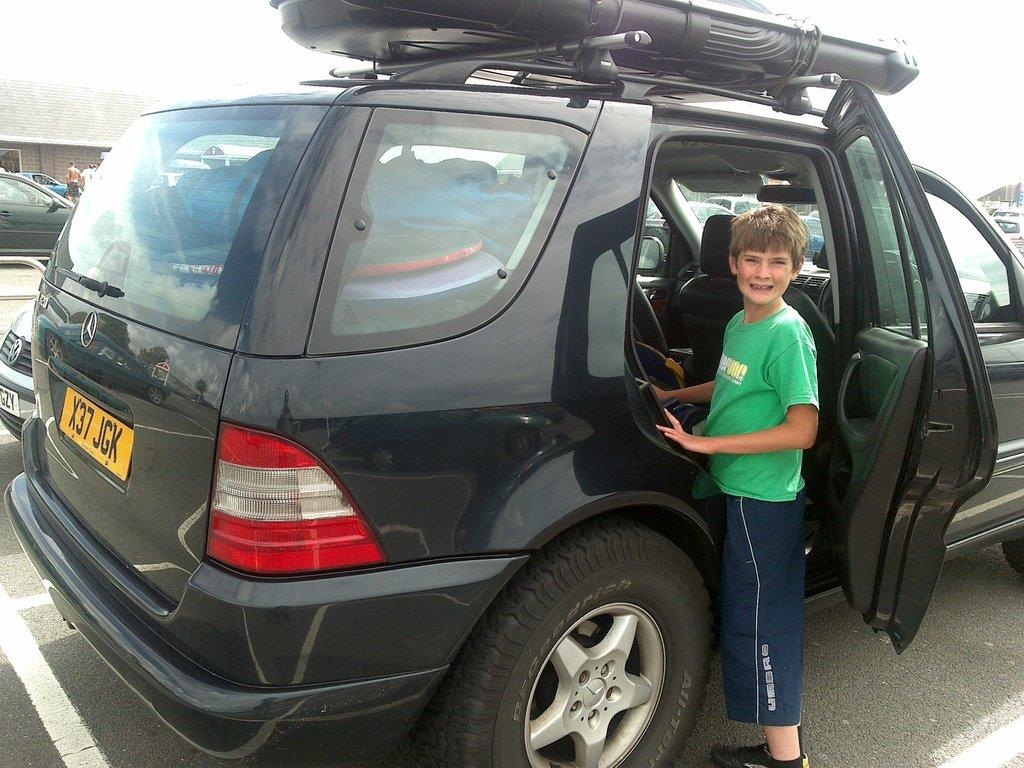What can be seen in the image related to vehicles? There are cars parked in the image. What is the boy doing in the image? The boy is standing and opening the door of a car. How would you describe the weather based on the image? The sky is cloudy in the image. What type of structure is visible in the image? There is a building visible in the image. Can you see a ball being played with in the image? There is no ball present in the image. Is the boy riding a bike in the image? The boy is not riding a bike in the image; he is standing and opening the door of a car. 